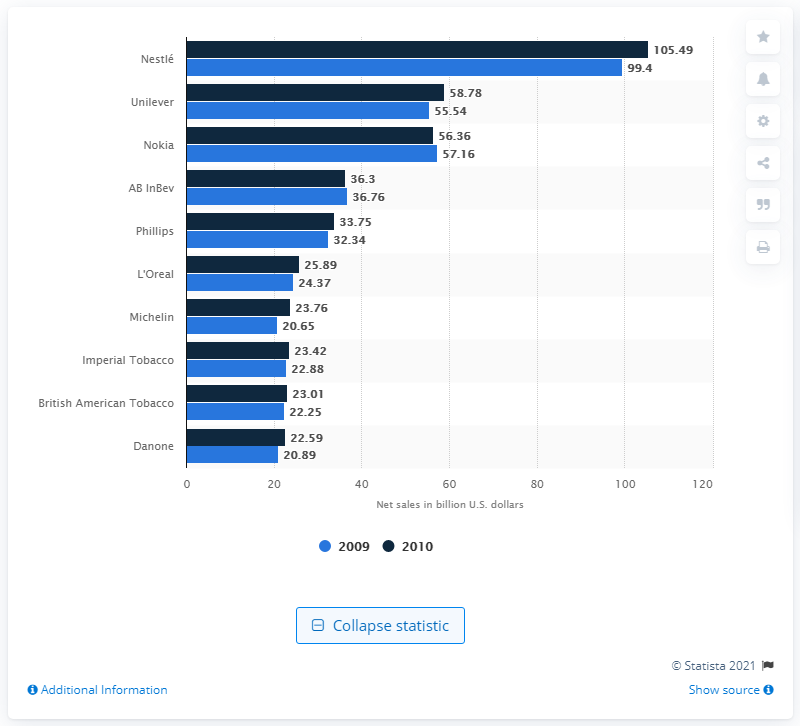Highlight a few significant elements in this photo. In 2010, Unilever was the second largest consumer goods manufacturer in Europe. 